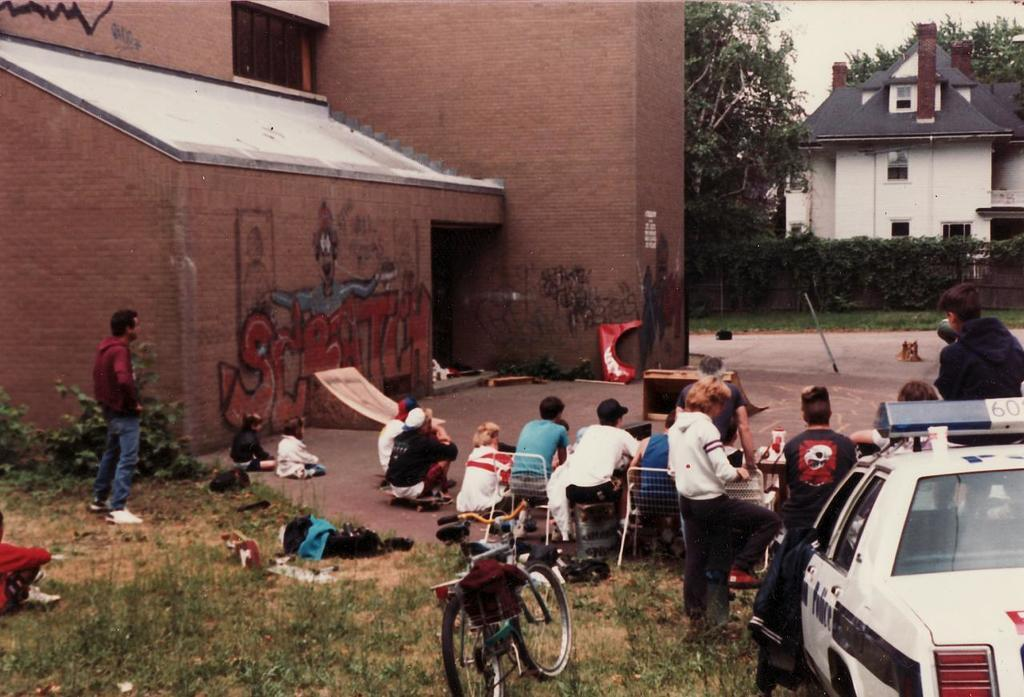What type of vehicle is present in the image? There is a car in the image. What other mode of transportation can be seen in the image? There is a bicycle in the image. What type of natural environment is visible in the image? There is grass in the image. What type of furniture is present in the image? There are chairs in the image. What type of structures are visible in the image? There are buildings with windows in the image. What type of vegetation is visible in the image? There are trees in the image. Can you describe the group of people in the image? There is a group of people in the image, with some sitting and some standing. What type of plate is being used by the ghost in the image? There is no ghost present in the image, and therefore no plate being used by a ghost. What type of room is visible in the image? The image does not show a room; it features a car, bicycle, grass, chairs, buildings, trees, and a group of people. 